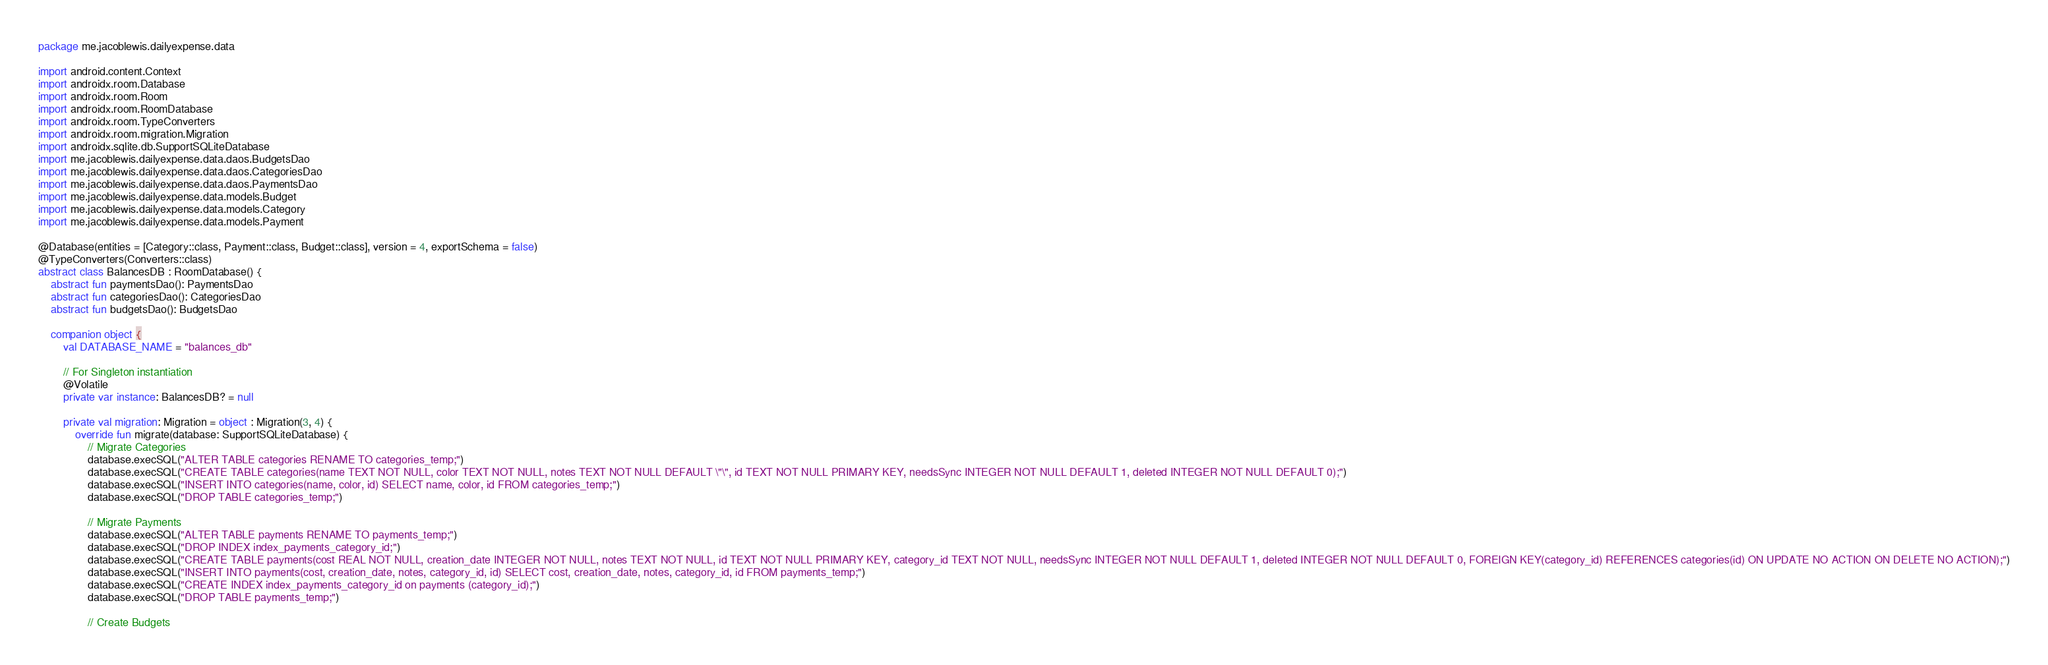Convert code to text. <code><loc_0><loc_0><loc_500><loc_500><_Kotlin_>package me.jacoblewis.dailyexpense.data

import android.content.Context
import androidx.room.Database
import androidx.room.Room
import androidx.room.RoomDatabase
import androidx.room.TypeConverters
import androidx.room.migration.Migration
import androidx.sqlite.db.SupportSQLiteDatabase
import me.jacoblewis.dailyexpense.data.daos.BudgetsDao
import me.jacoblewis.dailyexpense.data.daos.CategoriesDao
import me.jacoblewis.dailyexpense.data.daos.PaymentsDao
import me.jacoblewis.dailyexpense.data.models.Budget
import me.jacoblewis.dailyexpense.data.models.Category
import me.jacoblewis.dailyexpense.data.models.Payment

@Database(entities = [Category::class, Payment::class, Budget::class], version = 4, exportSchema = false)
@TypeConverters(Converters::class)
abstract class BalancesDB : RoomDatabase() {
    abstract fun paymentsDao(): PaymentsDao
    abstract fun categoriesDao(): CategoriesDao
    abstract fun budgetsDao(): BudgetsDao

    companion object {
        val DATABASE_NAME = "balances_db"

        // For Singleton instantiation
        @Volatile
        private var instance: BalancesDB? = null

        private val migration: Migration = object : Migration(3, 4) {
            override fun migrate(database: SupportSQLiteDatabase) {
                // Migrate Categories
                database.execSQL("ALTER TABLE categories RENAME TO categories_temp;")
                database.execSQL("CREATE TABLE categories(name TEXT NOT NULL, color TEXT NOT NULL, notes TEXT NOT NULL DEFAULT \"\", id TEXT NOT NULL PRIMARY KEY, needsSync INTEGER NOT NULL DEFAULT 1, deleted INTEGER NOT NULL DEFAULT 0);")
                database.execSQL("INSERT INTO categories(name, color, id) SELECT name, color, id FROM categories_temp;")
                database.execSQL("DROP TABLE categories_temp;")

                // Migrate Payments
                database.execSQL("ALTER TABLE payments RENAME TO payments_temp;")
                database.execSQL("DROP INDEX index_payments_category_id;")
                database.execSQL("CREATE TABLE payments(cost REAL NOT NULL, creation_date INTEGER NOT NULL, notes TEXT NOT NULL, id TEXT NOT NULL PRIMARY KEY, category_id TEXT NOT NULL, needsSync INTEGER NOT NULL DEFAULT 1, deleted INTEGER NOT NULL DEFAULT 0, FOREIGN KEY(category_id) REFERENCES categories(id) ON UPDATE NO ACTION ON DELETE NO ACTION);")
                database.execSQL("INSERT INTO payments(cost, creation_date, notes, category_id, id) SELECT cost, creation_date, notes, category_id, id FROM payments_temp;")
                database.execSQL("CREATE INDEX index_payments_category_id on payments (category_id);")
                database.execSQL("DROP TABLE payments_temp;")

                // Create Budgets</code> 